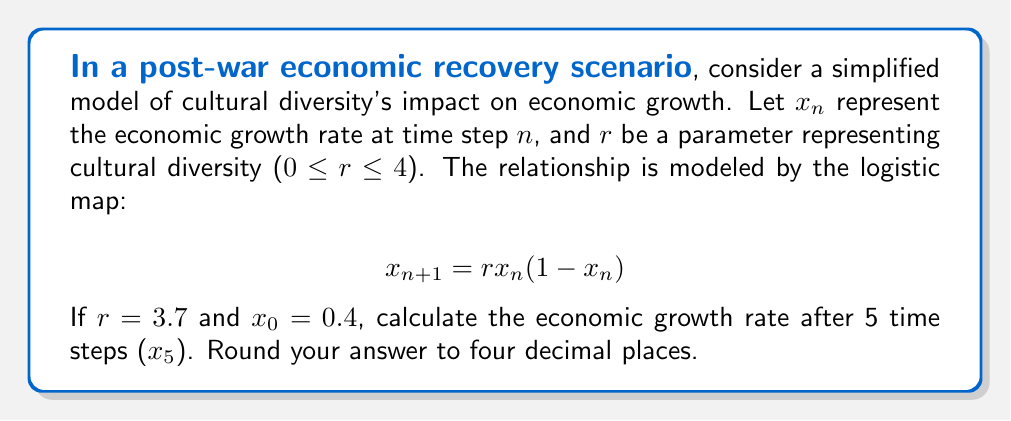Solve this math problem. To solve this problem, we'll iterate the logistic map equation for 5 time steps:

1) Start with $x_0 = 0.4$ and $r = 3.7$

2) Calculate $x_1$:
   $x_1 = 3.7 * 0.4 * (1-0.4) = 0.888$

3) Calculate $x_2$:
   $x_2 = 3.7 * 0.888 * (1-0.888) = 0.3684864$

4) Calculate $x_3$:
   $x_3 = 3.7 * 0.3684864 * (1-0.3684864) = 0.8611954$

5) Calculate $x_4$:
   $x_4 = 3.7 * 0.8611954 * (1-0.8611954) = 0.4431262$

6) Calculate $x_5$:
   $x_5 = 3.7 * 0.4431262 * (1-0.4431262) = 0.9132709$

7) Round to four decimal places: 0.9133

This demonstrates how small changes in initial conditions can lead to significantly different outcomes over time, a key principle in chaos theory.
Answer: 0.9133 